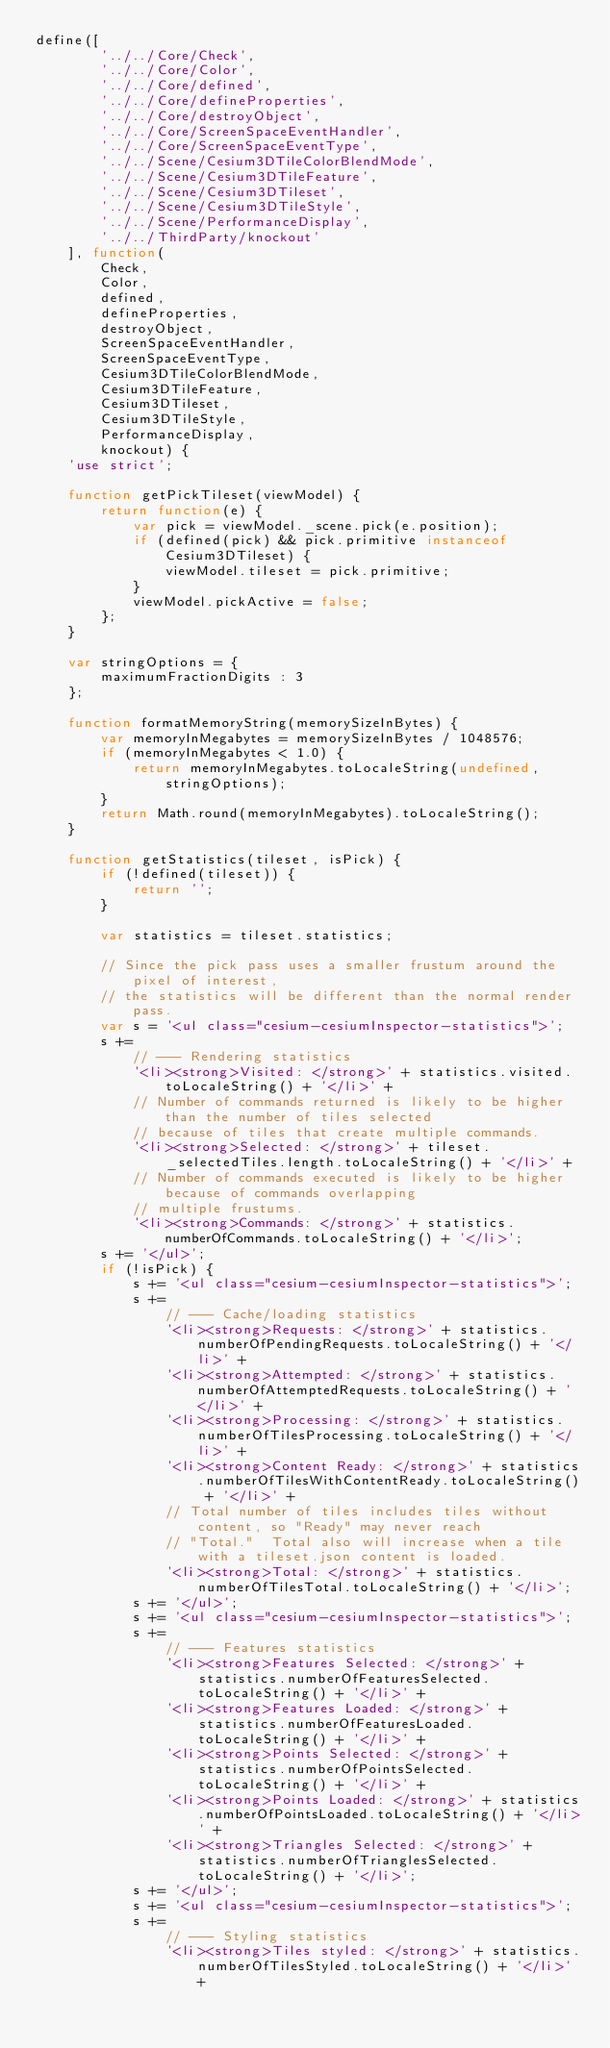Convert code to text. <code><loc_0><loc_0><loc_500><loc_500><_JavaScript_>define([
        '../../Core/Check',
        '../../Core/Color',
        '../../Core/defined',
        '../../Core/defineProperties',
        '../../Core/destroyObject',
        '../../Core/ScreenSpaceEventHandler',
        '../../Core/ScreenSpaceEventType',
        '../../Scene/Cesium3DTileColorBlendMode',
        '../../Scene/Cesium3DTileFeature',
        '../../Scene/Cesium3DTileset',
        '../../Scene/Cesium3DTileStyle',
        '../../Scene/PerformanceDisplay',
        '../../ThirdParty/knockout'
    ], function(
        Check,
        Color,
        defined,
        defineProperties,
        destroyObject,
        ScreenSpaceEventHandler,
        ScreenSpaceEventType,
        Cesium3DTileColorBlendMode,
        Cesium3DTileFeature,
        Cesium3DTileset,
        Cesium3DTileStyle,
        PerformanceDisplay,
        knockout) {
    'use strict';

    function getPickTileset(viewModel) {
        return function(e) {
            var pick = viewModel._scene.pick(e.position);
            if (defined(pick) && pick.primitive instanceof Cesium3DTileset) {
                viewModel.tileset = pick.primitive;
            }
            viewModel.pickActive = false;
        };
    }

    var stringOptions = {
        maximumFractionDigits : 3
    };

    function formatMemoryString(memorySizeInBytes) {
        var memoryInMegabytes = memorySizeInBytes / 1048576;
        if (memoryInMegabytes < 1.0) {
            return memoryInMegabytes.toLocaleString(undefined, stringOptions);
        }
        return Math.round(memoryInMegabytes).toLocaleString();
    }

    function getStatistics(tileset, isPick) {
        if (!defined(tileset)) {
            return '';
        }

        var statistics = tileset.statistics;

        // Since the pick pass uses a smaller frustum around the pixel of interest,
        // the statistics will be different than the normal render pass.
        var s = '<ul class="cesium-cesiumInspector-statistics">';
        s +=
            // --- Rendering statistics
            '<li><strong>Visited: </strong>' + statistics.visited.toLocaleString() + '</li>' +
            // Number of commands returned is likely to be higher than the number of tiles selected
            // because of tiles that create multiple commands.
            '<li><strong>Selected: </strong>' + tileset._selectedTiles.length.toLocaleString() + '</li>' +
            // Number of commands executed is likely to be higher because of commands overlapping
            // multiple frustums.
            '<li><strong>Commands: </strong>' + statistics.numberOfCommands.toLocaleString() + '</li>';
        s += '</ul>';
        if (!isPick) {
            s += '<ul class="cesium-cesiumInspector-statistics">';
            s +=
                // --- Cache/loading statistics
                '<li><strong>Requests: </strong>' + statistics.numberOfPendingRequests.toLocaleString() + '</li>' +
                '<li><strong>Attempted: </strong>' + statistics.numberOfAttemptedRequests.toLocaleString() + '</li>' +
                '<li><strong>Processing: </strong>' + statistics.numberOfTilesProcessing.toLocaleString() + '</li>' +
                '<li><strong>Content Ready: </strong>' + statistics.numberOfTilesWithContentReady.toLocaleString() + '</li>' +
                // Total number of tiles includes tiles without content, so "Ready" may never reach
                // "Total."  Total also will increase when a tile with a tileset.json content is loaded.
                '<li><strong>Total: </strong>' + statistics.numberOfTilesTotal.toLocaleString() + '</li>';
            s += '</ul>';
            s += '<ul class="cesium-cesiumInspector-statistics">';
            s +=
                // --- Features statistics
                '<li><strong>Features Selected: </strong>' + statistics.numberOfFeaturesSelected.toLocaleString() + '</li>' +
                '<li><strong>Features Loaded: </strong>' + statistics.numberOfFeaturesLoaded.toLocaleString() + '</li>' +
                '<li><strong>Points Selected: </strong>' + statistics.numberOfPointsSelected.toLocaleString() + '</li>' +
                '<li><strong>Points Loaded: </strong>' + statistics.numberOfPointsLoaded.toLocaleString() + '</li>' +
                '<li><strong>Triangles Selected: </strong>' + statistics.numberOfTrianglesSelected.toLocaleString() + '</li>';
            s += '</ul>';
            s += '<ul class="cesium-cesiumInspector-statistics">';
            s +=
                // --- Styling statistics
                '<li><strong>Tiles styled: </strong>' + statistics.numberOfTilesStyled.toLocaleString() + '</li>' +</code> 